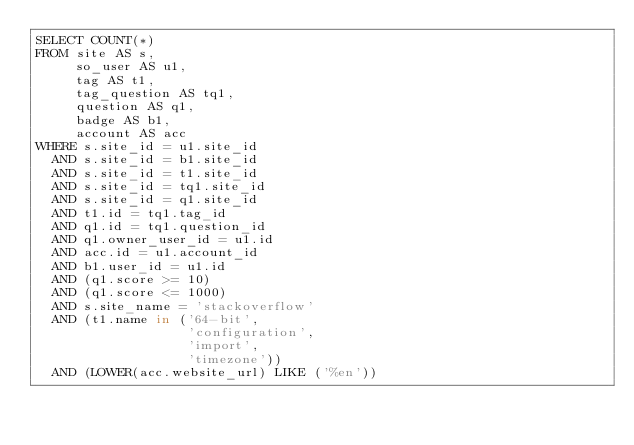Convert code to text. <code><loc_0><loc_0><loc_500><loc_500><_SQL_>SELECT COUNT(*)
FROM site AS s,
     so_user AS u1,
     tag AS t1,
     tag_question AS tq1,
     question AS q1,
     badge AS b1,
     account AS acc
WHERE s.site_id = u1.site_id
  AND s.site_id = b1.site_id
  AND s.site_id = t1.site_id
  AND s.site_id = tq1.site_id
  AND s.site_id = q1.site_id
  AND t1.id = tq1.tag_id
  AND q1.id = tq1.question_id
  AND q1.owner_user_id = u1.id
  AND acc.id = u1.account_id
  AND b1.user_id = u1.id
  AND (q1.score >= 10)
  AND (q1.score <= 1000)
  AND s.site_name = 'stackoverflow'
  AND (t1.name in ('64-bit',
                   'configuration',
                   'import',
                   'timezone'))
  AND (LOWER(acc.website_url) LIKE ('%en'))</code> 